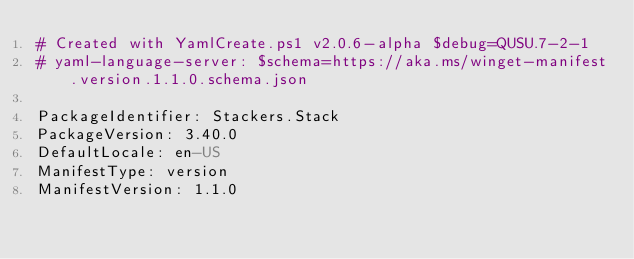Convert code to text. <code><loc_0><loc_0><loc_500><loc_500><_YAML_># Created with YamlCreate.ps1 v2.0.6-alpha $debug=QUSU.7-2-1
# yaml-language-server: $schema=https://aka.ms/winget-manifest.version.1.1.0.schema.json

PackageIdentifier: Stackers.Stack
PackageVersion: 3.40.0
DefaultLocale: en-US
ManifestType: version
ManifestVersion: 1.1.0
</code> 